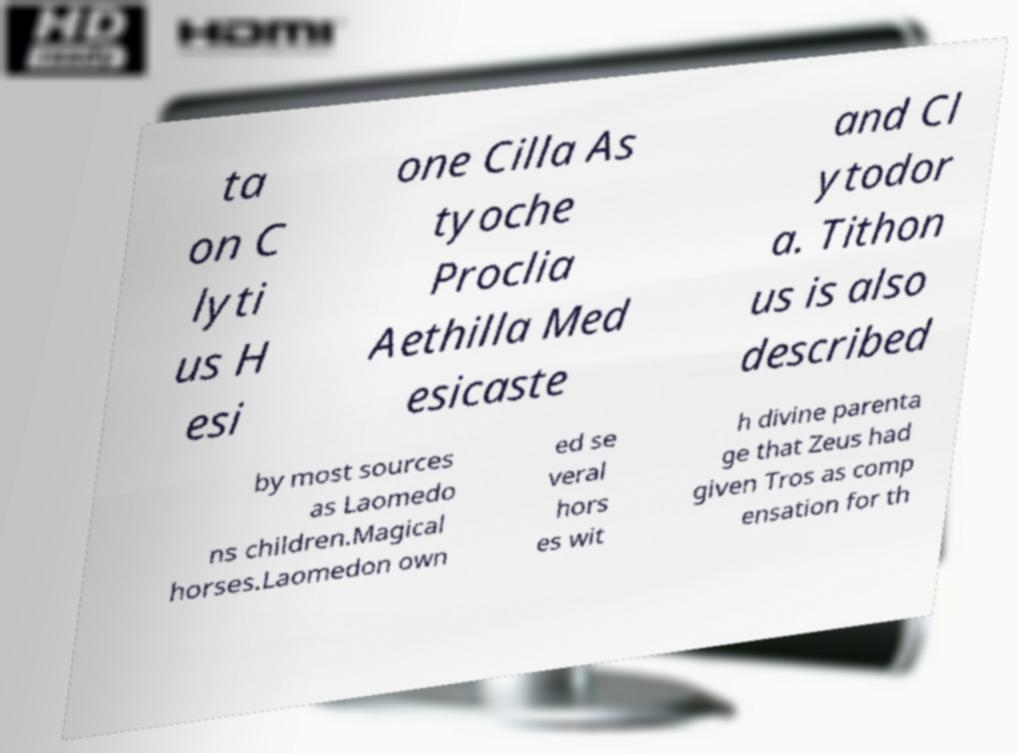Can you accurately transcribe the text from the provided image for me? ta on C lyti us H esi one Cilla As tyoche Proclia Aethilla Med esicaste and Cl ytodor a. Tithon us is also described by most sources as Laomedo ns children.Magical horses.Laomedon own ed se veral hors es wit h divine parenta ge that Zeus had given Tros as comp ensation for th 